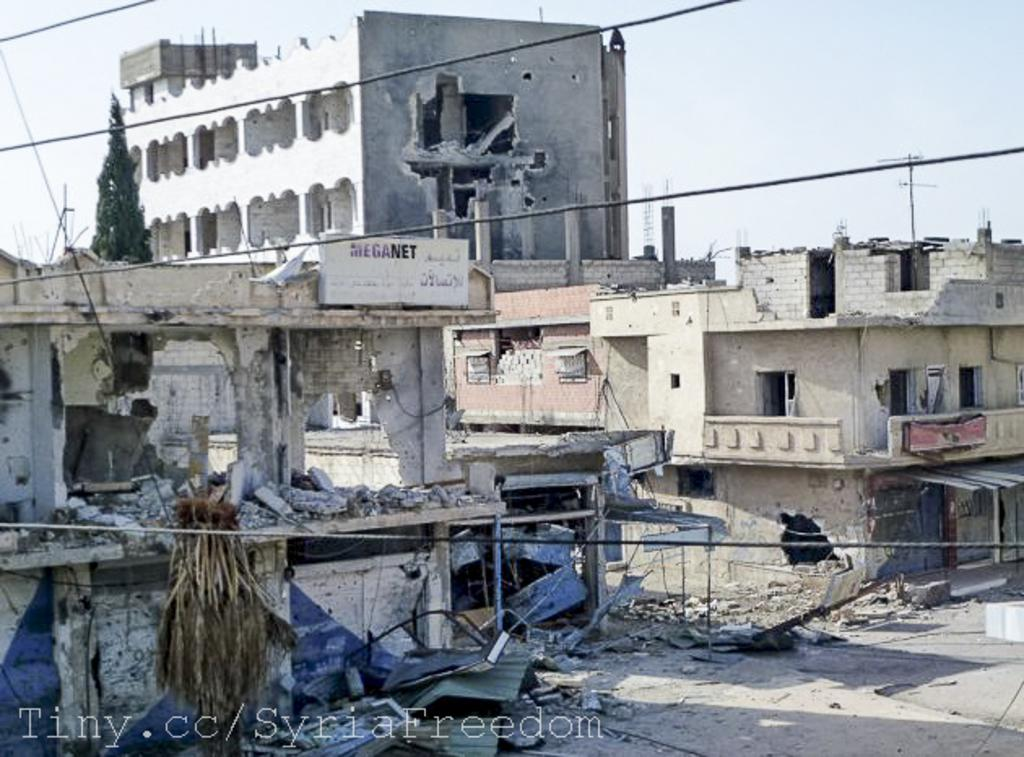What type of structures are visible in the image? There are house buildings in the image. Are all the buildings in good condition? No, some buildings appear to be broken. What can be seen on the path in the image? Debris from the broken buildings is present on the path. What is visible in the background of the image? The sky is visible in the background of the image. What type of drug is being distributed in the image? There is no indication of any drug distribution in the image; it features house buildings, some of which are broken, with debris on the path and a visible sky in the background. 